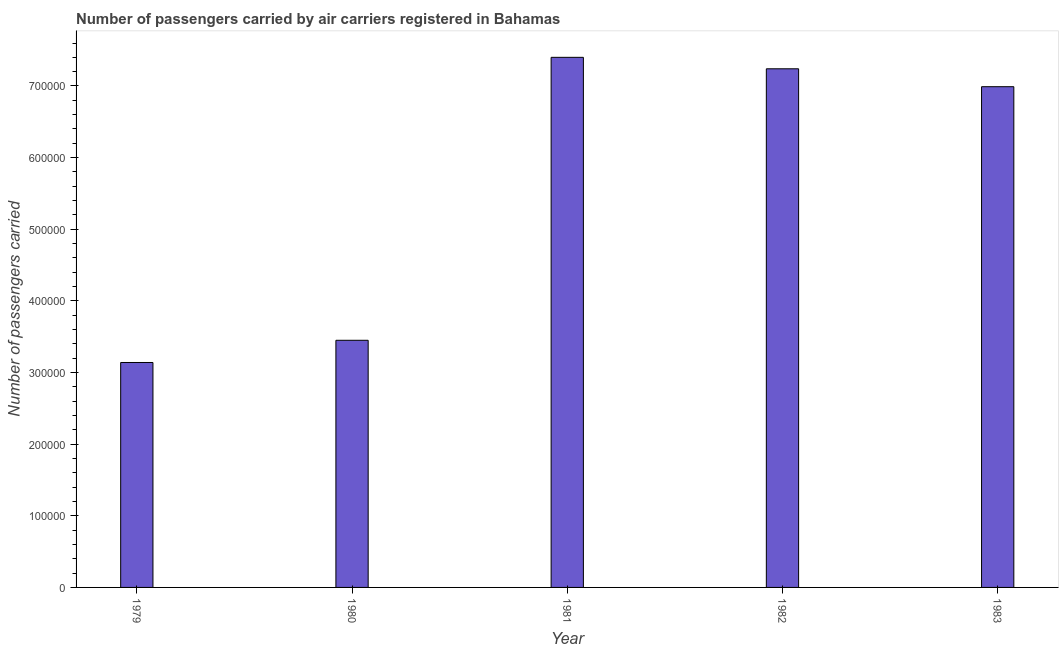Does the graph contain grids?
Your answer should be very brief. No. What is the title of the graph?
Make the answer very short. Number of passengers carried by air carriers registered in Bahamas. What is the label or title of the X-axis?
Ensure brevity in your answer.  Year. What is the label or title of the Y-axis?
Give a very brief answer. Number of passengers carried. What is the number of passengers carried in 1982?
Your answer should be very brief. 7.24e+05. Across all years, what is the maximum number of passengers carried?
Offer a terse response. 7.40e+05. Across all years, what is the minimum number of passengers carried?
Your answer should be compact. 3.14e+05. In which year was the number of passengers carried minimum?
Keep it short and to the point. 1979. What is the sum of the number of passengers carried?
Offer a terse response. 2.82e+06. What is the difference between the number of passengers carried in 1982 and 1983?
Your answer should be very brief. 2.50e+04. What is the average number of passengers carried per year?
Offer a terse response. 5.64e+05. What is the median number of passengers carried?
Provide a succinct answer. 6.99e+05. In how many years, is the number of passengers carried greater than 520000 ?
Provide a short and direct response. 3. Do a majority of the years between 1982 and 1979 (inclusive) have number of passengers carried greater than 340000 ?
Your answer should be very brief. Yes. What is the ratio of the number of passengers carried in 1981 to that in 1983?
Keep it short and to the point. 1.06. Is the number of passengers carried in 1981 less than that in 1983?
Provide a short and direct response. No. What is the difference between the highest and the second highest number of passengers carried?
Provide a short and direct response. 1.60e+04. What is the difference between the highest and the lowest number of passengers carried?
Make the answer very short. 4.26e+05. In how many years, is the number of passengers carried greater than the average number of passengers carried taken over all years?
Your response must be concise. 3. How many bars are there?
Provide a succinct answer. 5. Are all the bars in the graph horizontal?
Keep it short and to the point. No. How many years are there in the graph?
Make the answer very short. 5. What is the Number of passengers carried in 1979?
Your answer should be very brief. 3.14e+05. What is the Number of passengers carried of 1980?
Your response must be concise. 3.45e+05. What is the Number of passengers carried in 1981?
Ensure brevity in your answer.  7.40e+05. What is the Number of passengers carried in 1982?
Offer a terse response. 7.24e+05. What is the Number of passengers carried of 1983?
Offer a terse response. 6.99e+05. What is the difference between the Number of passengers carried in 1979 and 1980?
Offer a terse response. -3.10e+04. What is the difference between the Number of passengers carried in 1979 and 1981?
Provide a succinct answer. -4.26e+05. What is the difference between the Number of passengers carried in 1979 and 1982?
Provide a succinct answer. -4.10e+05. What is the difference between the Number of passengers carried in 1979 and 1983?
Your answer should be compact. -3.85e+05. What is the difference between the Number of passengers carried in 1980 and 1981?
Your response must be concise. -3.95e+05. What is the difference between the Number of passengers carried in 1980 and 1982?
Keep it short and to the point. -3.79e+05. What is the difference between the Number of passengers carried in 1980 and 1983?
Your answer should be compact. -3.54e+05. What is the difference between the Number of passengers carried in 1981 and 1982?
Offer a terse response. 1.60e+04. What is the difference between the Number of passengers carried in 1981 and 1983?
Your answer should be compact. 4.10e+04. What is the difference between the Number of passengers carried in 1982 and 1983?
Offer a very short reply. 2.50e+04. What is the ratio of the Number of passengers carried in 1979 to that in 1980?
Your answer should be compact. 0.91. What is the ratio of the Number of passengers carried in 1979 to that in 1981?
Your answer should be compact. 0.42. What is the ratio of the Number of passengers carried in 1979 to that in 1982?
Offer a terse response. 0.43. What is the ratio of the Number of passengers carried in 1979 to that in 1983?
Make the answer very short. 0.45. What is the ratio of the Number of passengers carried in 1980 to that in 1981?
Give a very brief answer. 0.47. What is the ratio of the Number of passengers carried in 1980 to that in 1982?
Offer a very short reply. 0.48. What is the ratio of the Number of passengers carried in 1980 to that in 1983?
Your response must be concise. 0.49. What is the ratio of the Number of passengers carried in 1981 to that in 1982?
Offer a very short reply. 1.02. What is the ratio of the Number of passengers carried in 1981 to that in 1983?
Make the answer very short. 1.06. What is the ratio of the Number of passengers carried in 1982 to that in 1983?
Give a very brief answer. 1.04. 